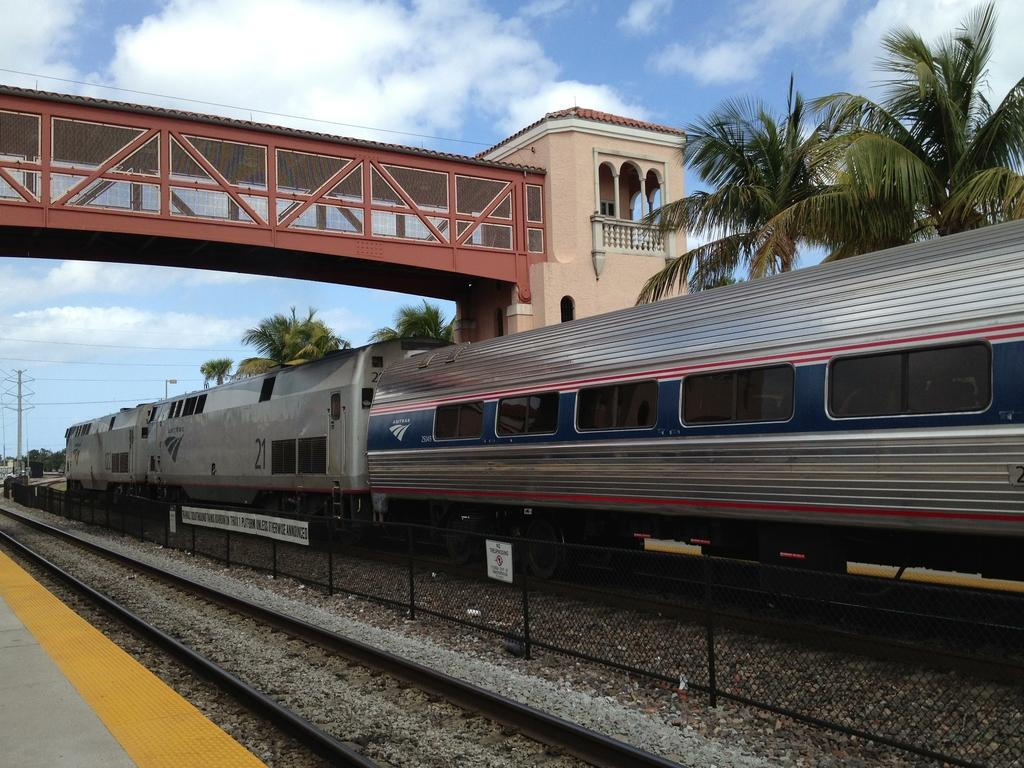What is the main subject of the image? The main subject of the image is a train. Where is the train located in the image? The train is on a track. What can be seen behind the train in the image? There are trees behind the train. What is above the train in the image? There is a foot over bridge above the train. What is visible in the sky in the image? The sky is visible in the image, and clouds are present. What type of yam is being used as a boundary marker in the image? There is no yam or boundary marker present in the image; it features a train on a track with trees, a foot over bridge, and a sky with clouds. 